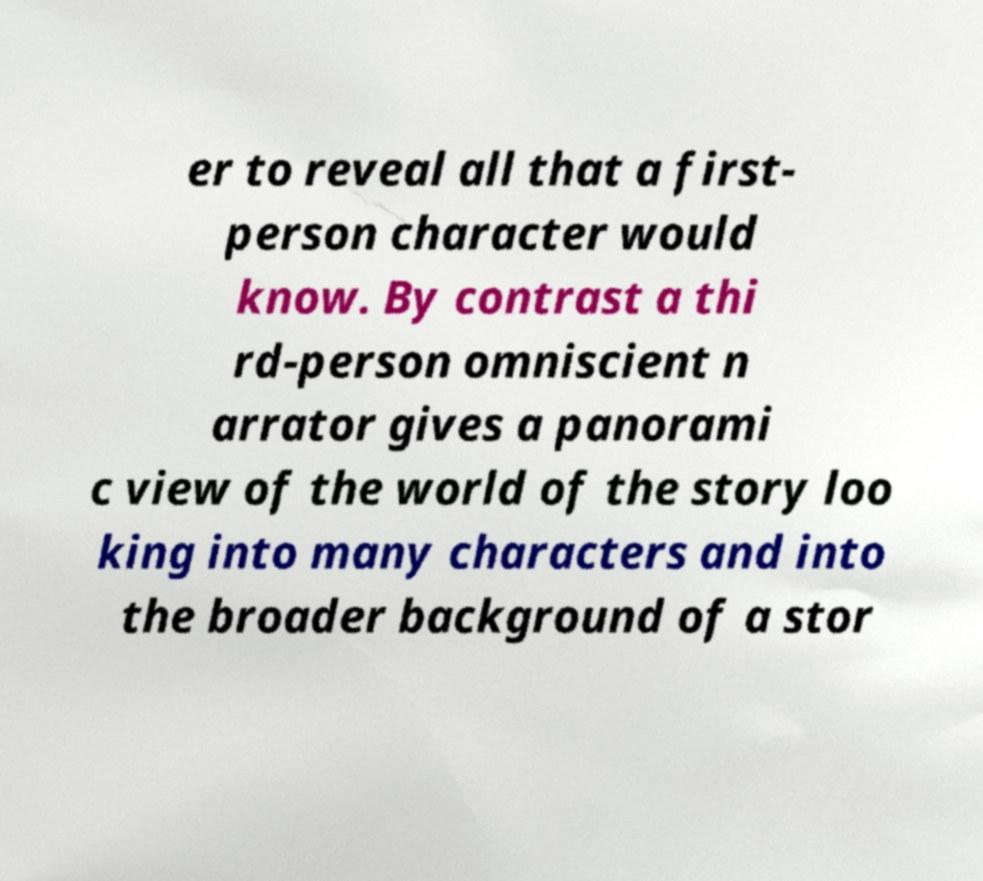Please identify and transcribe the text found in this image. er to reveal all that a first- person character would know. By contrast a thi rd-person omniscient n arrator gives a panorami c view of the world of the story loo king into many characters and into the broader background of a stor 